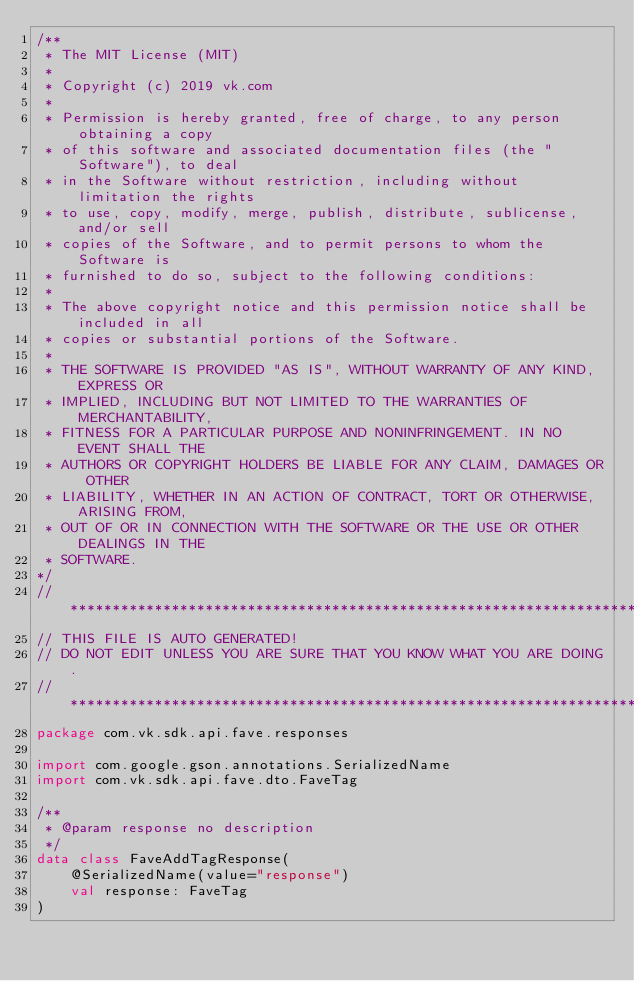Convert code to text. <code><loc_0><loc_0><loc_500><loc_500><_Kotlin_>/**
 * The MIT License (MIT)
 *
 * Copyright (c) 2019 vk.com
 *
 * Permission is hereby granted, free of charge, to any person obtaining a copy
 * of this software and associated documentation files (the "Software"), to deal
 * in the Software without restriction, including without limitation the rights
 * to use, copy, modify, merge, publish, distribute, sublicense, and/or sell
 * copies of the Software, and to permit persons to whom the Software is
 * furnished to do so, subject to the following conditions:
 *
 * The above copyright notice and this permission notice shall be included in all
 * copies or substantial portions of the Software.
 *
 * THE SOFTWARE IS PROVIDED "AS IS", WITHOUT WARRANTY OF ANY KIND, EXPRESS OR
 * IMPLIED, INCLUDING BUT NOT LIMITED TO THE WARRANTIES OF MERCHANTABILITY,
 * FITNESS FOR A PARTICULAR PURPOSE AND NONINFRINGEMENT. IN NO EVENT SHALL THE
 * AUTHORS OR COPYRIGHT HOLDERS BE LIABLE FOR ANY CLAIM, DAMAGES OR OTHER
 * LIABILITY, WHETHER IN AN ACTION OF CONTRACT, TORT OR OTHERWISE, ARISING FROM,
 * OUT OF OR IN CONNECTION WITH THE SOFTWARE OR THE USE OR OTHER DEALINGS IN THE
 * SOFTWARE.
*/
// *********************************************************************
// THIS FILE IS AUTO GENERATED!
// DO NOT EDIT UNLESS YOU ARE SURE THAT YOU KNOW WHAT YOU ARE DOING.
// *********************************************************************
package com.vk.sdk.api.fave.responses

import com.google.gson.annotations.SerializedName
import com.vk.sdk.api.fave.dto.FaveTag

/**
 * @param response no description
 */
data class FaveAddTagResponse(
    @SerializedName(value="response")
    val response: FaveTag
)
</code> 